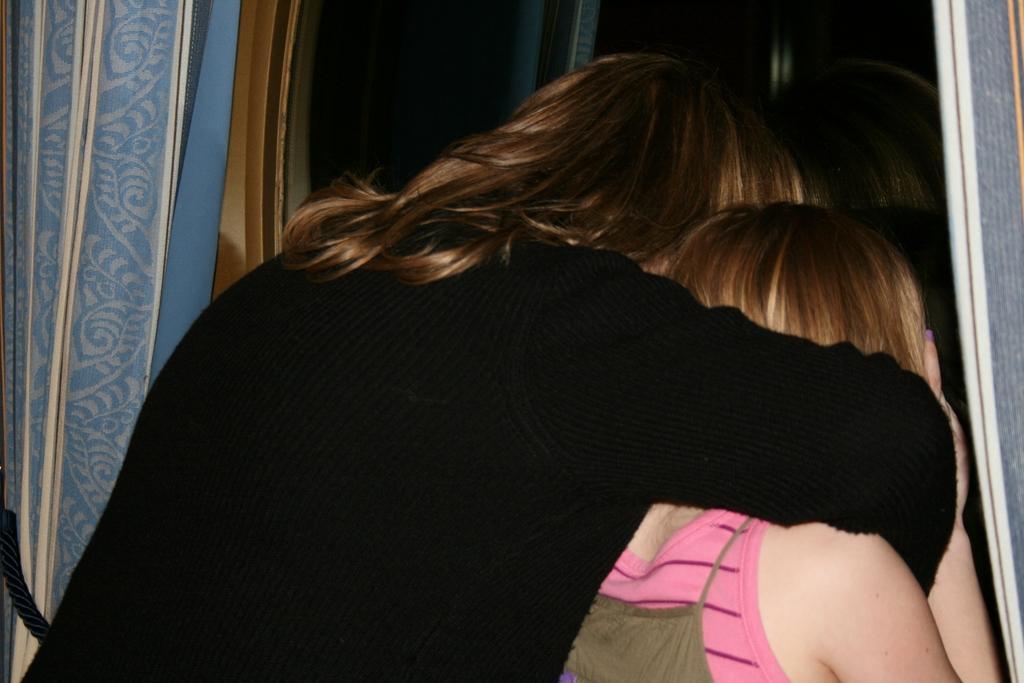Could you give a brief overview of what you see in this image? Here in this picture we can see two women standing over a place and peeping through a window over there and we can see window curtains present on either side over there. 